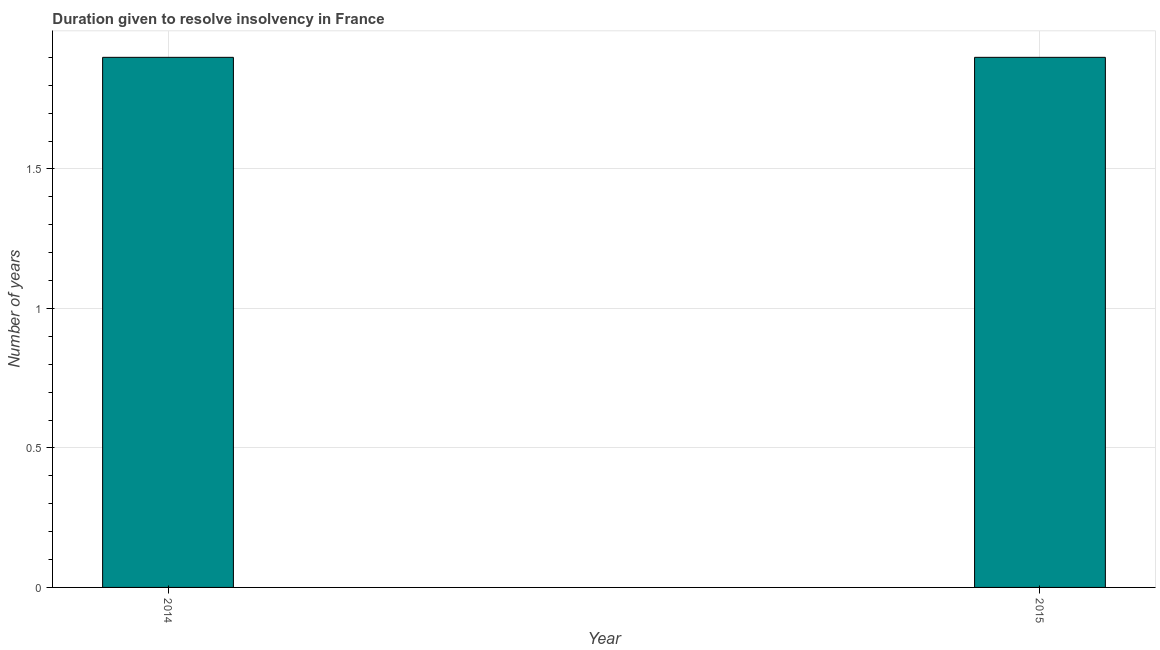Does the graph contain grids?
Offer a terse response. Yes. What is the title of the graph?
Ensure brevity in your answer.  Duration given to resolve insolvency in France. What is the label or title of the X-axis?
Your answer should be very brief. Year. What is the label or title of the Y-axis?
Your answer should be very brief. Number of years. What is the number of years to resolve insolvency in 2015?
Your answer should be compact. 1.9. Across all years, what is the minimum number of years to resolve insolvency?
Offer a terse response. 1.9. In which year was the number of years to resolve insolvency minimum?
Keep it short and to the point. 2014. What is the sum of the number of years to resolve insolvency?
Offer a very short reply. 3.8. What is the median number of years to resolve insolvency?
Make the answer very short. 1.9. In how many years, is the number of years to resolve insolvency greater than 0.1 ?
Offer a very short reply. 2. Is the number of years to resolve insolvency in 2014 less than that in 2015?
Provide a succinct answer. No. In how many years, is the number of years to resolve insolvency greater than the average number of years to resolve insolvency taken over all years?
Offer a very short reply. 0. How many bars are there?
Your answer should be compact. 2. Are the values on the major ticks of Y-axis written in scientific E-notation?
Provide a succinct answer. No. What is the Number of years in 2015?
Give a very brief answer. 1.9. 